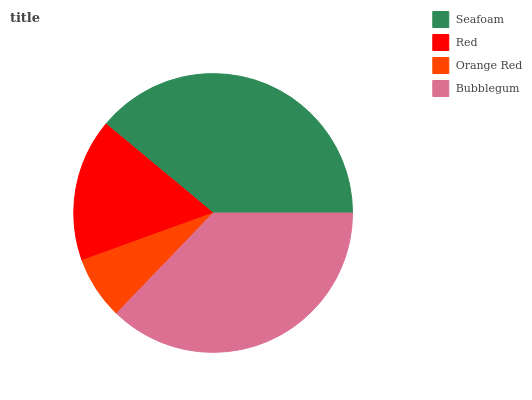Is Orange Red the minimum?
Answer yes or no. Yes. Is Seafoam the maximum?
Answer yes or no. Yes. Is Red the minimum?
Answer yes or no. No. Is Red the maximum?
Answer yes or no. No. Is Seafoam greater than Red?
Answer yes or no. Yes. Is Red less than Seafoam?
Answer yes or no. Yes. Is Red greater than Seafoam?
Answer yes or no. No. Is Seafoam less than Red?
Answer yes or no. No. Is Bubblegum the high median?
Answer yes or no. Yes. Is Red the low median?
Answer yes or no. Yes. Is Seafoam the high median?
Answer yes or no. No. Is Seafoam the low median?
Answer yes or no. No. 